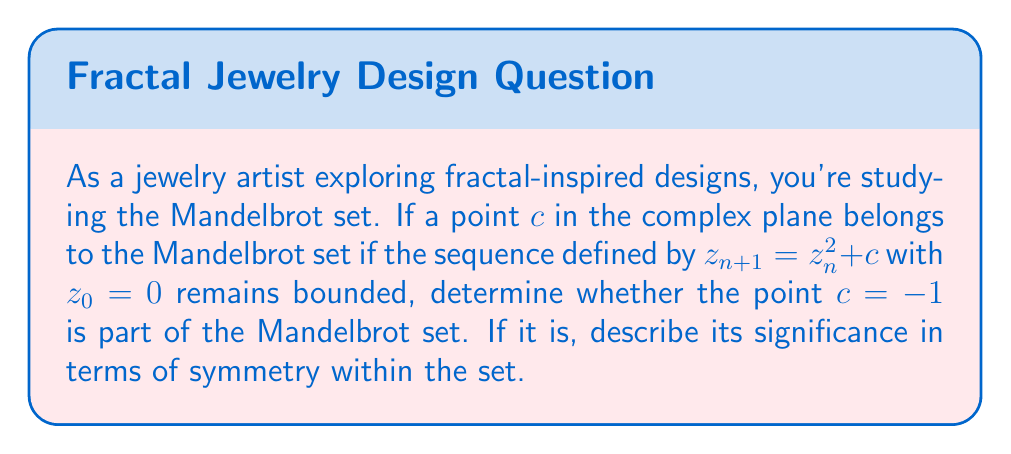Solve this math problem. To determine if $c = -1$ is part of the Mandelbrot set, we need to iterate the function $f(z) = z^2 + c$ with $z_0 = 0$ and $c = -1$:

1) $z_0 = 0$
2) $z_1 = 0^2 + (-1) = -1$
3) $z_2 = (-1)^2 + (-1) = 0$
4) $z_3 = 0^2 + (-1) = -1$
5) $z_4 = (-1)^2 + (-1) = 0$

We can see that the sequence alternates between 0 and -1 indefinitely. Since these values are bounded (they don't approach infinity), the point $c = -1$ is indeed part of the Mandelbrot set.

The significance of $c = -1$ in terms of symmetry:

1) It lies on the real axis of the complex plane, which is an axis of symmetry for the Mandelbrot set.

2) It represents a period-2 orbit in the dynamics of the function $f(z) = z^2 + c$. This means it's part of the period-doubling sequence that forms one of the main cardioid bulbs of the Mandelbrot set.

3) The point $c = -1$ is located at the intersection of the main cardioid and the period-2 bulb, making it a cusp point of the set. This location is crucial in understanding the overall structure and symmetry of the Mandelbrot set.

4) It's one of the few points in the Mandelbrot set where we can easily predict and visualize the behavior without complex calculations, making it valuable for artists exploring fractal patterns.

This point exemplifies how simple mathematical rules can generate complex, symmetric patterns in fractal art, which could be inspiring for creating intricate jewelry designs.
Answer: Yes, the point $c = -1$ is part of the Mandelbrot set. It is significant for the set's symmetry as it lies on the real axis (an axis of symmetry), represents a period-2 orbit, and is located at a cusp point between the main cardioid and the period-2 bulb of the Mandelbrot set. 